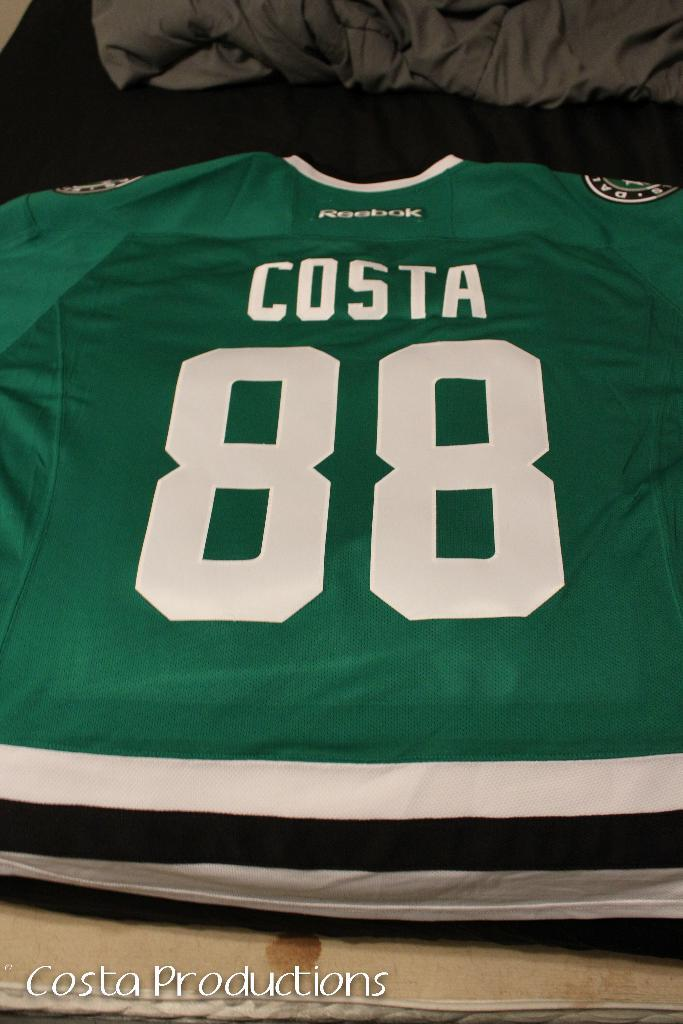<image>
Write a terse but informative summary of the picture. Reebok made a jersey for player 88, costa. 